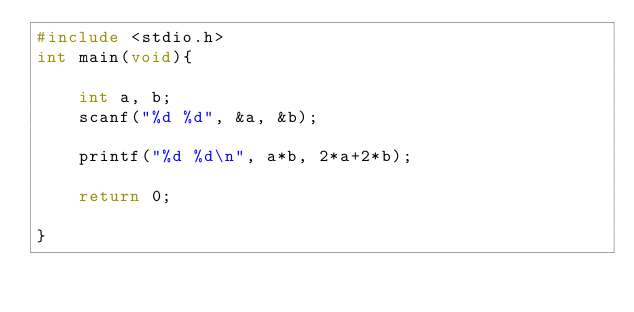<code> <loc_0><loc_0><loc_500><loc_500><_C_>#include <stdio.h>
int main(void){
    
    int a, b;
    scanf("%d %d", &a, &b);
    
    printf("%d %d\n", a*b, 2*a+2*b);
    
    return 0;
    
}

</code> 